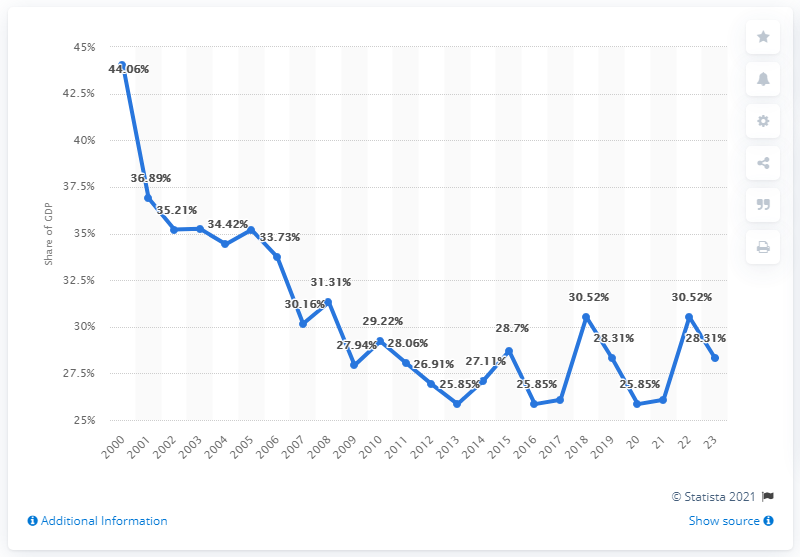Specify some key components in this picture. In 2000, Russia's share of export in its Gross Domestic Product (GDP) was 44.06%. In total, 24 years have been considered. In 2001, there was a significant decline in exports. During the period of 2018 and 2019, exports of goods and services accounted for 28.31% of the GDP of Russia. 